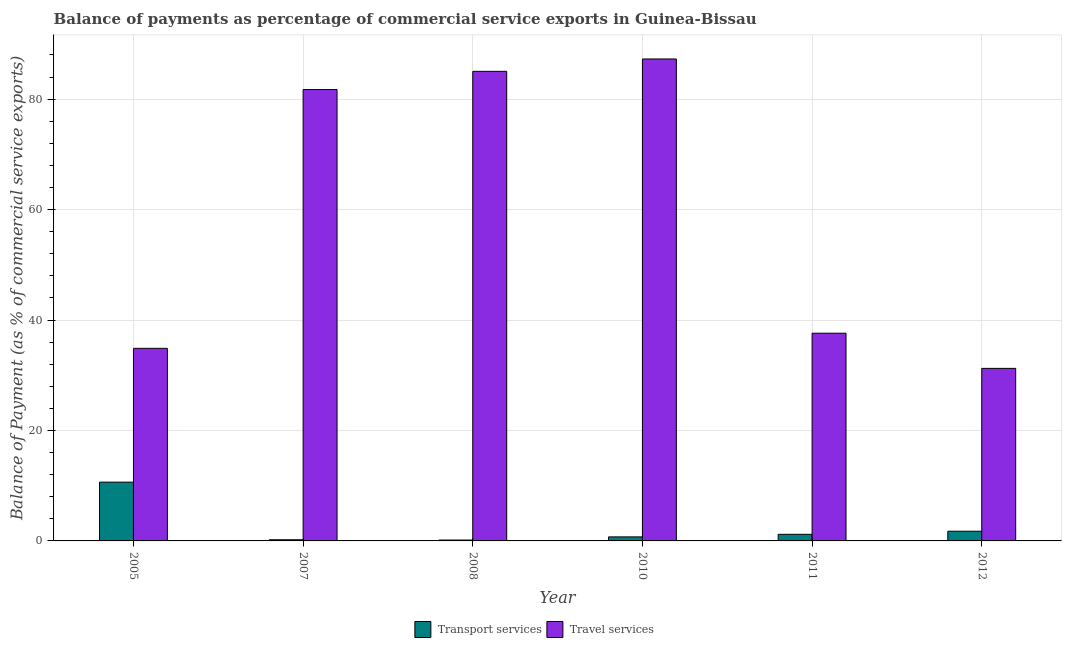Are the number of bars per tick equal to the number of legend labels?
Make the answer very short. Yes. How many bars are there on the 6th tick from the left?
Provide a short and direct response. 2. How many bars are there on the 1st tick from the right?
Ensure brevity in your answer.  2. What is the label of the 2nd group of bars from the left?
Provide a short and direct response. 2007. What is the balance of payments of transport services in 2007?
Keep it short and to the point. 0.21. Across all years, what is the maximum balance of payments of transport services?
Offer a very short reply. 10.64. Across all years, what is the minimum balance of payments of travel services?
Offer a terse response. 31.25. In which year was the balance of payments of transport services maximum?
Your response must be concise. 2005. In which year was the balance of payments of travel services minimum?
Your response must be concise. 2012. What is the total balance of payments of transport services in the graph?
Make the answer very short. 14.69. What is the difference between the balance of payments of travel services in 2007 and that in 2012?
Your answer should be very brief. 50.5. What is the difference between the balance of payments of travel services in 2012 and the balance of payments of transport services in 2011?
Offer a terse response. -6.37. What is the average balance of payments of travel services per year?
Your answer should be compact. 59.63. In the year 2011, what is the difference between the balance of payments of travel services and balance of payments of transport services?
Provide a succinct answer. 0. In how many years, is the balance of payments of travel services greater than 76 %?
Provide a short and direct response. 3. What is the ratio of the balance of payments of travel services in 2005 to that in 2011?
Ensure brevity in your answer.  0.93. Is the difference between the balance of payments of travel services in 2007 and 2012 greater than the difference between the balance of payments of transport services in 2007 and 2012?
Keep it short and to the point. No. What is the difference between the highest and the second highest balance of payments of transport services?
Make the answer very short. 8.88. What is the difference between the highest and the lowest balance of payments of transport services?
Keep it short and to the point. 10.48. Is the sum of the balance of payments of transport services in 2011 and 2012 greater than the maximum balance of payments of travel services across all years?
Offer a very short reply. No. What does the 1st bar from the left in 2012 represents?
Your answer should be very brief. Transport services. What does the 2nd bar from the right in 2007 represents?
Give a very brief answer. Transport services. What is the difference between two consecutive major ticks on the Y-axis?
Provide a succinct answer. 20. Are the values on the major ticks of Y-axis written in scientific E-notation?
Make the answer very short. No. What is the title of the graph?
Offer a very short reply. Balance of payments as percentage of commercial service exports in Guinea-Bissau. Does "Primary school" appear as one of the legend labels in the graph?
Provide a short and direct response. No. What is the label or title of the Y-axis?
Provide a short and direct response. Balance of Payment (as % of commercial service exports). What is the Balance of Payment (as % of commercial service exports) of Transport services in 2005?
Offer a terse response. 10.64. What is the Balance of Payment (as % of commercial service exports) of Travel services in 2005?
Give a very brief answer. 34.88. What is the Balance of Payment (as % of commercial service exports) of Transport services in 2007?
Your answer should be very brief. 0.21. What is the Balance of Payment (as % of commercial service exports) of Travel services in 2007?
Your response must be concise. 81.74. What is the Balance of Payment (as % of commercial service exports) of Transport services in 2008?
Provide a short and direct response. 0.16. What is the Balance of Payment (as % of commercial service exports) of Travel services in 2008?
Your answer should be very brief. 85.04. What is the Balance of Payment (as % of commercial service exports) of Transport services in 2010?
Your answer should be compact. 0.73. What is the Balance of Payment (as % of commercial service exports) in Travel services in 2010?
Offer a very short reply. 87.27. What is the Balance of Payment (as % of commercial service exports) in Transport services in 2011?
Your answer should be compact. 1.19. What is the Balance of Payment (as % of commercial service exports) of Travel services in 2011?
Provide a short and direct response. 37.61. What is the Balance of Payment (as % of commercial service exports) in Transport services in 2012?
Keep it short and to the point. 1.76. What is the Balance of Payment (as % of commercial service exports) of Travel services in 2012?
Give a very brief answer. 31.25. Across all years, what is the maximum Balance of Payment (as % of commercial service exports) of Transport services?
Make the answer very short. 10.64. Across all years, what is the maximum Balance of Payment (as % of commercial service exports) of Travel services?
Keep it short and to the point. 87.27. Across all years, what is the minimum Balance of Payment (as % of commercial service exports) of Transport services?
Provide a short and direct response. 0.16. Across all years, what is the minimum Balance of Payment (as % of commercial service exports) of Travel services?
Give a very brief answer. 31.25. What is the total Balance of Payment (as % of commercial service exports) of Transport services in the graph?
Your answer should be very brief. 14.69. What is the total Balance of Payment (as % of commercial service exports) of Travel services in the graph?
Ensure brevity in your answer.  357.79. What is the difference between the Balance of Payment (as % of commercial service exports) in Transport services in 2005 and that in 2007?
Provide a succinct answer. 10.43. What is the difference between the Balance of Payment (as % of commercial service exports) in Travel services in 2005 and that in 2007?
Give a very brief answer. -46.87. What is the difference between the Balance of Payment (as % of commercial service exports) of Transport services in 2005 and that in 2008?
Make the answer very short. 10.48. What is the difference between the Balance of Payment (as % of commercial service exports) of Travel services in 2005 and that in 2008?
Give a very brief answer. -50.16. What is the difference between the Balance of Payment (as % of commercial service exports) in Transport services in 2005 and that in 2010?
Give a very brief answer. 9.91. What is the difference between the Balance of Payment (as % of commercial service exports) of Travel services in 2005 and that in 2010?
Your answer should be compact. -52.4. What is the difference between the Balance of Payment (as % of commercial service exports) of Transport services in 2005 and that in 2011?
Your answer should be very brief. 9.45. What is the difference between the Balance of Payment (as % of commercial service exports) in Travel services in 2005 and that in 2011?
Keep it short and to the point. -2.74. What is the difference between the Balance of Payment (as % of commercial service exports) of Transport services in 2005 and that in 2012?
Offer a very short reply. 8.88. What is the difference between the Balance of Payment (as % of commercial service exports) of Travel services in 2005 and that in 2012?
Ensure brevity in your answer.  3.63. What is the difference between the Balance of Payment (as % of commercial service exports) of Transport services in 2007 and that in 2008?
Give a very brief answer. 0.05. What is the difference between the Balance of Payment (as % of commercial service exports) in Travel services in 2007 and that in 2008?
Give a very brief answer. -3.29. What is the difference between the Balance of Payment (as % of commercial service exports) in Transport services in 2007 and that in 2010?
Your answer should be very brief. -0.52. What is the difference between the Balance of Payment (as % of commercial service exports) of Travel services in 2007 and that in 2010?
Make the answer very short. -5.53. What is the difference between the Balance of Payment (as % of commercial service exports) in Transport services in 2007 and that in 2011?
Give a very brief answer. -0.98. What is the difference between the Balance of Payment (as % of commercial service exports) of Travel services in 2007 and that in 2011?
Offer a terse response. 44.13. What is the difference between the Balance of Payment (as % of commercial service exports) of Transport services in 2007 and that in 2012?
Offer a terse response. -1.55. What is the difference between the Balance of Payment (as % of commercial service exports) of Travel services in 2007 and that in 2012?
Give a very brief answer. 50.5. What is the difference between the Balance of Payment (as % of commercial service exports) in Transport services in 2008 and that in 2010?
Give a very brief answer. -0.57. What is the difference between the Balance of Payment (as % of commercial service exports) in Travel services in 2008 and that in 2010?
Your answer should be compact. -2.24. What is the difference between the Balance of Payment (as % of commercial service exports) in Transport services in 2008 and that in 2011?
Provide a succinct answer. -1.03. What is the difference between the Balance of Payment (as % of commercial service exports) of Travel services in 2008 and that in 2011?
Offer a terse response. 47.42. What is the difference between the Balance of Payment (as % of commercial service exports) of Transport services in 2008 and that in 2012?
Your response must be concise. -1.6. What is the difference between the Balance of Payment (as % of commercial service exports) of Travel services in 2008 and that in 2012?
Offer a terse response. 53.79. What is the difference between the Balance of Payment (as % of commercial service exports) of Transport services in 2010 and that in 2011?
Give a very brief answer. -0.46. What is the difference between the Balance of Payment (as % of commercial service exports) in Travel services in 2010 and that in 2011?
Provide a succinct answer. 49.66. What is the difference between the Balance of Payment (as % of commercial service exports) in Transport services in 2010 and that in 2012?
Your answer should be very brief. -1.03. What is the difference between the Balance of Payment (as % of commercial service exports) in Travel services in 2010 and that in 2012?
Keep it short and to the point. 56.03. What is the difference between the Balance of Payment (as % of commercial service exports) in Transport services in 2011 and that in 2012?
Provide a short and direct response. -0.56. What is the difference between the Balance of Payment (as % of commercial service exports) in Travel services in 2011 and that in 2012?
Make the answer very short. 6.37. What is the difference between the Balance of Payment (as % of commercial service exports) of Transport services in 2005 and the Balance of Payment (as % of commercial service exports) of Travel services in 2007?
Your answer should be compact. -71.1. What is the difference between the Balance of Payment (as % of commercial service exports) of Transport services in 2005 and the Balance of Payment (as % of commercial service exports) of Travel services in 2008?
Provide a succinct answer. -74.39. What is the difference between the Balance of Payment (as % of commercial service exports) in Transport services in 2005 and the Balance of Payment (as % of commercial service exports) in Travel services in 2010?
Offer a terse response. -76.63. What is the difference between the Balance of Payment (as % of commercial service exports) of Transport services in 2005 and the Balance of Payment (as % of commercial service exports) of Travel services in 2011?
Offer a terse response. -26.97. What is the difference between the Balance of Payment (as % of commercial service exports) of Transport services in 2005 and the Balance of Payment (as % of commercial service exports) of Travel services in 2012?
Your response must be concise. -20.6. What is the difference between the Balance of Payment (as % of commercial service exports) in Transport services in 2007 and the Balance of Payment (as % of commercial service exports) in Travel services in 2008?
Provide a succinct answer. -84.83. What is the difference between the Balance of Payment (as % of commercial service exports) in Transport services in 2007 and the Balance of Payment (as % of commercial service exports) in Travel services in 2010?
Provide a succinct answer. -87.06. What is the difference between the Balance of Payment (as % of commercial service exports) in Transport services in 2007 and the Balance of Payment (as % of commercial service exports) in Travel services in 2011?
Provide a succinct answer. -37.4. What is the difference between the Balance of Payment (as % of commercial service exports) in Transport services in 2007 and the Balance of Payment (as % of commercial service exports) in Travel services in 2012?
Your answer should be compact. -31.04. What is the difference between the Balance of Payment (as % of commercial service exports) in Transport services in 2008 and the Balance of Payment (as % of commercial service exports) in Travel services in 2010?
Offer a very short reply. -87.11. What is the difference between the Balance of Payment (as % of commercial service exports) in Transport services in 2008 and the Balance of Payment (as % of commercial service exports) in Travel services in 2011?
Offer a very short reply. -37.45. What is the difference between the Balance of Payment (as % of commercial service exports) of Transport services in 2008 and the Balance of Payment (as % of commercial service exports) of Travel services in 2012?
Offer a very short reply. -31.09. What is the difference between the Balance of Payment (as % of commercial service exports) of Transport services in 2010 and the Balance of Payment (as % of commercial service exports) of Travel services in 2011?
Your response must be concise. -36.88. What is the difference between the Balance of Payment (as % of commercial service exports) in Transport services in 2010 and the Balance of Payment (as % of commercial service exports) in Travel services in 2012?
Your answer should be compact. -30.52. What is the difference between the Balance of Payment (as % of commercial service exports) in Transport services in 2011 and the Balance of Payment (as % of commercial service exports) in Travel services in 2012?
Keep it short and to the point. -30.05. What is the average Balance of Payment (as % of commercial service exports) of Transport services per year?
Your answer should be compact. 2.45. What is the average Balance of Payment (as % of commercial service exports) of Travel services per year?
Give a very brief answer. 59.63. In the year 2005, what is the difference between the Balance of Payment (as % of commercial service exports) in Transport services and Balance of Payment (as % of commercial service exports) in Travel services?
Give a very brief answer. -24.23. In the year 2007, what is the difference between the Balance of Payment (as % of commercial service exports) of Transport services and Balance of Payment (as % of commercial service exports) of Travel services?
Your answer should be compact. -81.53. In the year 2008, what is the difference between the Balance of Payment (as % of commercial service exports) in Transport services and Balance of Payment (as % of commercial service exports) in Travel services?
Your response must be concise. -84.88. In the year 2010, what is the difference between the Balance of Payment (as % of commercial service exports) of Transport services and Balance of Payment (as % of commercial service exports) of Travel services?
Ensure brevity in your answer.  -86.54. In the year 2011, what is the difference between the Balance of Payment (as % of commercial service exports) of Transport services and Balance of Payment (as % of commercial service exports) of Travel services?
Provide a short and direct response. -36.42. In the year 2012, what is the difference between the Balance of Payment (as % of commercial service exports) in Transport services and Balance of Payment (as % of commercial service exports) in Travel services?
Your answer should be very brief. -29.49. What is the ratio of the Balance of Payment (as % of commercial service exports) in Transport services in 2005 to that in 2007?
Your answer should be compact. 50.76. What is the ratio of the Balance of Payment (as % of commercial service exports) in Travel services in 2005 to that in 2007?
Provide a short and direct response. 0.43. What is the ratio of the Balance of Payment (as % of commercial service exports) of Transport services in 2005 to that in 2008?
Your response must be concise. 66.55. What is the ratio of the Balance of Payment (as % of commercial service exports) in Travel services in 2005 to that in 2008?
Give a very brief answer. 0.41. What is the ratio of the Balance of Payment (as % of commercial service exports) of Transport services in 2005 to that in 2010?
Offer a terse response. 14.58. What is the ratio of the Balance of Payment (as % of commercial service exports) of Travel services in 2005 to that in 2010?
Make the answer very short. 0.4. What is the ratio of the Balance of Payment (as % of commercial service exports) in Transport services in 2005 to that in 2011?
Your answer should be very brief. 8.91. What is the ratio of the Balance of Payment (as % of commercial service exports) of Travel services in 2005 to that in 2011?
Provide a short and direct response. 0.93. What is the ratio of the Balance of Payment (as % of commercial service exports) of Transport services in 2005 to that in 2012?
Your answer should be compact. 6.05. What is the ratio of the Balance of Payment (as % of commercial service exports) of Travel services in 2005 to that in 2012?
Give a very brief answer. 1.12. What is the ratio of the Balance of Payment (as % of commercial service exports) of Transport services in 2007 to that in 2008?
Keep it short and to the point. 1.31. What is the ratio of the Balance of Payment (as % of commercial service exports) in Travel services in 2007 to that in 2008?
Offer a very short reply. 0.96. What is the ratio of the Balance of Payment (as % of commercial service exports) of Transport services in 2007 to that in 2010?
Your answer should be compact. 0.29. What is the ratio of the Balance of Payment (as % of commercial service exports) in Travel services in 2007 to that in 2010?
Provide a succinct answer. 0.94. What is the ratio of the Balance of Payment (as % of commercial service exports) in Transport services in 2007 to that in 2011?
Your response must be concise. 0.18. What is the ratio of the Balance of Payment (as % of commercial service exports) in Travel services in 2007 to that in 2011?
Your answer should be compact. 2.17. What is the ratio of the Balance of Payment (as % of commercial service exports) of Transport services in 2007 to that in 2012?
Provide a short and direct response. 0.12. What is the ratio of the Balance of Payment (as % of commercial service exports) of Travel services in 2007 to that in 2012?
Ensure brevity in your answer.  2.62. What is the ratio of the Balance of Payment (as % of commercial service exports) of Transport services in 2008 to that in 2010?
Provide a succinct answer. 0.22. What is the ratio of the Balance of Payment (as % of commercial service exports) in Travel services in 2008 to that in 2010?
Offer a terse response. 0.97. What is the ratio of the Balance of Payment (as % of commercial service exports) of Transport services in 2008 to that in 2011?
Your response must be concise. 0.13. What is the ratio of the Balance of Payment (as % of commercial service exports) of Travel services in 2008 to that in 2011?
Give a very brief answer. 2.26. What is the ratio of the Balance of Payment (as % of commercial service exports) in Transport services in 2008 to that in 2012?
Offer a terse response. 0.09. What is the ratio of the Balance of Payment (as % of commercial service exports) of Travel services in 2008 to that in 2012?
Provide a short and direct response. 2.72. What is the ratio of the Balance of Payment (as % of commercial service exports) in Transport services in 2010 to that in 2011?
Provide a short and direct response. 0.61. What is the ratio of the Balance of Payment (as % of commercial service exports) in Travel services in 2010 to that in 2011?
Ensure brevity in your answer.  2.32. What is the ratio of the Balance of Payment (as % of commercial service exports) of Transport services in 2010 to that in 2012?
Your response must be concise. 0.42. What is the ratio of the Balance of Payment (as % of commercial service exports) in Travel services in 2010 to that in 2012?
Ensure brevity in your answer.  2.79. What is the ratio of the Balance of Payment (as % of commercial service exports) of Transport services in 2011 to that in 2012?
Provide a short and direct response. 0.68. What is the ratio of the Balance of Payment (as % of commercial service exports) in Travel services in 2011 to that in 2012?
Your response must be concise. 1.2. What is the difference between the highest and the second highest Balance of Payment (as % of commercial service exports) in Transport services?
Provide a short and direct response. 8.88. What is the difference between the highest and the second highest Balance of Payment (as % of commercial service exports) in Travel services?
Keep it short and to the point. 2.24. What is the difference between the highest and the lowest Balance of Payment (as % of commercial service exports) of Transport services?
Provide a succinct answer. 10.48. What is the difference between the highest and the lowest Balance of Payment (as % of commercial service exports) in Travel services?
Your response must be concise. 56.03. 